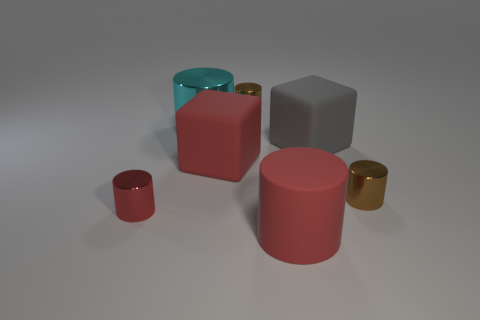There is a red rubber thing that is the same shape as the big cyan metal thing; what is its size?
Give a very brief answer. Large. Is the number of cyan cylinders in front of the big red cylinder less than the number of tiny shiny things that are behind the gray object?
Provide a short and direct response. Yes. What color is the cylinder that is the same material as the big gray block?
Provide a short and direct response. Red. There is a big red matte object in front of the tiny red thing; are there any brown cylinders that are on the left side of it?
Ensure brevity in your answer.  Yes. The metallic cylinder that is the same size as the red block is what color?
Offer a very short reply. Cyan. What number of things are either cyan cylinders or large things?
Make the answer very short. 4. What is the size of the block that is right of the small brown metallic thing on the left side of the brown metal thing on the right side of the big red matte cylinder?
Provide a succinct answer. Large. How many tiny cylinders have the same color as the large matte cylinder?
Your answer should be very brief. 1. What number of large cubes are the same material as the gray thing?
Offer a terse response. 1. What number of things are large gray metallic blocks or tiny brown things that are to the left of the big gray thing?
Your answer should be compact. 1. 